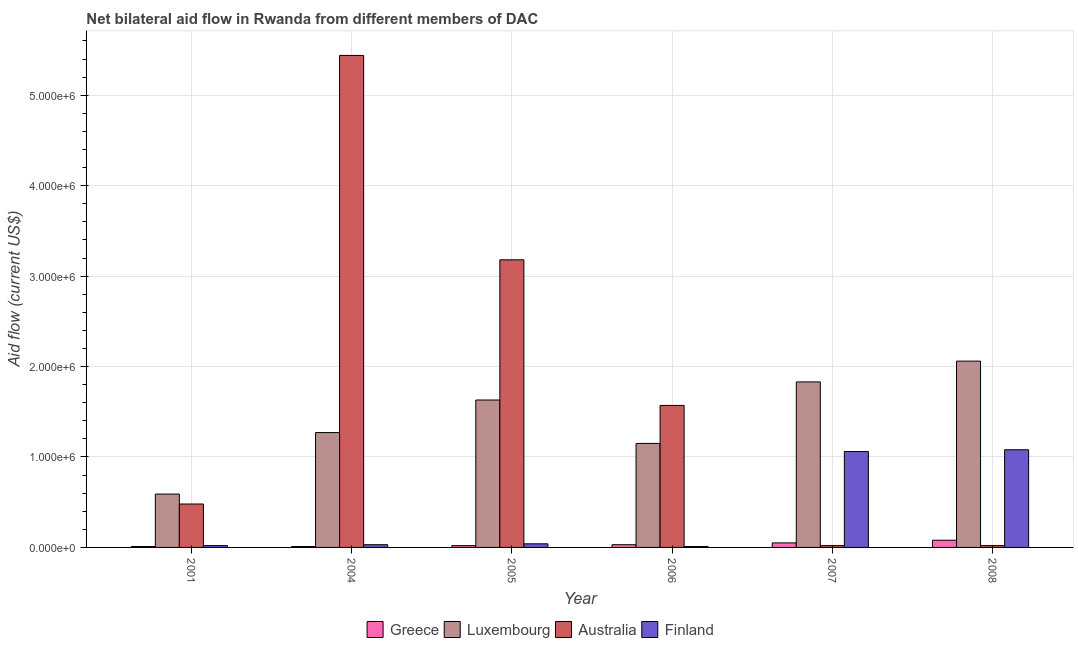How many groups of bars are there?
Offer a very short reply. 6. Are the number of bars per tick equal to the number of legend labels?
Give a very brief answer. Yes. How many bars are there on the 6th tick from the left?
Your response must be concise. 4. How many bars are there on the 1st tick from the right?
Your answer should be very brief. 4. What is the label of the 3rd group of bars from the left?
Give a very brief answer. 2005. What is the amount of aid given by greece in 2004?
Offer a very short reply. 10000. Across all years, what is the maximum amount of aid given by luxembourg?
Provide a short and direct response. 2.06e+06. Across all years, what is the minimum amount of aid given by finland?
Make the answer very short. 10000. In which year was the amount of aid given by luxembourg maximum?
Your response must be concise. 2008. What is the total amount of aid given by greece in the graph?
Make the answer very short. 2.00e+05. What is the difference between the amount of aid given by finland in 2001 and that in 2006?
Make the answer very short. 10000. What is the difference between the amount of aid given by finland in 2008 and the amount of aid given by luxembourg in 2004?
Provide a short and direct response. 1.05e+06. What is the average amount of aid given by greece per year?
Your response must be concise. 3.33e+04. In how many years, is the amount of aid given by australia greater than 3800000 US$?
Your answer should be very brief. 1. What is the ratio of the amount of aid given by finland in 2006 to that in 2008?
Offer a terse response. 0.01. Is the difference between the amount of aid given by finland in 2004 and 2007 greater than the difference between the amount of aid given by luxembourg in 2004 and 2007?
Offer a terse response. No. What is the difference between the highest and the second highest amount of aid given by luxembourg?
Ensure brevity in your answer.  2.30e+05. What is the difference between the highest and the lowest amount of aid given by greece?
Ensure brevity in your answer.  7.00e+04. In how many years, is the amount of aid given by australia greater than the average amount of aid given by australia taken over all years?
Offer a terse response. 2. Is it the case that in every year, the sum of the amount of aid given by luxembourg and amount of aid given by greece is greater than the sum of amount of aid given by australia and amount of aid given by finland?
Your answer should be very brief. Yes. What does the 2nd bar from the right in 2006 represents?
Give a very brief answer. Australia. Is it the case that in every year, the sum of the amount of aid given by greece and amount of aid given by luxembourg is greater than the amount of aid given by australia?
Make the answer very short. No. Are all the bars in the graph horizontal?
Provide a succinct answer. No. What is the difference between two consecutive major ticks on the Y-axis?
Your answer should be compact. 1.00e+06. Does the graph contain any zero values?
Make the answer very short. No. Does the graph contain grids?
Provide a succinct answer. Yes. What is the title of the graph?
Offer a terse response. Net bilateral aid flow in Rwanda from different members of DAC. Does "Interest Payments" appear as one of the legend labels in the graph?
Offer a very short reply. No. What is the Aid flow (current US$) of Greece in 2001?
Keep it short and to the point. 10000. What is the Aid flow (current US$) in Luxembourg in 2001?
Keep it short and to the point. 5.90e+05. What is the Aid flow (current US$) in Australia in 2001?
Keep it short and to the point. 4.80e+05. What is the Aid flow (current US$) in Finland in 2001?
Keep it short and to the point. 2.00e+04. What is the Aid flow (current US$) in Greece in 2004?
Provide a succinct answer. 10000. What is the Aid flow (current US$) of Luxembourg in 2004?
Offer a very short reply. 1.27e+06. What is the Aid flow (current US$) of Australia in 2004?
Offer a terse response. 5.44e+06. What is the Aid flow (current US$) of Finland in 2004?
Offer a very short reply. 3.00e+04. What is the Aid flow (current US$) in Luxembourg in 2005?
Ensure brevity in your answer.  1.63e+06. What is the Aid flow (current US$) in Australia in 2005?
Provide a short and direct response. 3.18e+06. What is the Aid flow (current US$) of Finland in 2005?
Provide a succinct answer. 4.00e+04. What is the Aid flow (current US$) of Luxembourg in 2006?
Keep it short and to the point. 1.15e+06. What is the Aid flow (current US$) in Australia in 2006?
Make the answer very short. 1.57e+06. What is the Aid flow (current US$) in Greece in 2007?
Offer a terse response. 5.00e+04. What is the Aid flow (current US$) of Luxembourg in 2007?
Offer a very short reply. 1.83e+06. What is the Aid flow (current US$) of Australia in 2007?
Give a very brief answer. 2.00e+04. What is the Aid flow (current US$) of Finland in 2007?
Ensure brevity in your answer.  1.06e+06. What is the Aid flow (current US$) in Greece in 2008?
Your answer should be very brief. 8.00e+04. What is the Aid flow (current US$) in Luxembourg in 2008?
Offer a very short reply. 2.06e+06. What is the Aid flow (current US$) in Finland in 2008?
Your answer should be compact. 1.08e+06. Across all years, what is the maximum Aid flow (current US$) of Greece?
Ensure brevity in your answer.  8.00e+04. Across all years, what is the maximum Aid flow (current US$) in Luxembourg?
Ensure brevity in your answer.  2.06e+06. Across all years, what is the maximum Aid flow (current US$) of Australia?
Make the answer very short. 5.44e+06. Across all years, what is the maximum Aid flow (current US$) in Finland?
Offer a terse response. 1.08e+06. Across all years, what is the minimum Aid flow (current US$) of Luxembourg?
Make the answer very short. 5.90e+05. Across all years, what is the minimum Aid flow (current US$) in Australia?
Ensure brevity in your answer.  2.00e+04. What is the total Aid flow (current US$) in Greece in the graph?
Offer a very short reply. 2.00e+05. What is the total Aid flow (current US$) in Luxembourg in the graph?
Keep it short and to the point. 8.53e+06. What is the total Aid flow (current US$) of Australia in the graph?
Provide a short and direct response. 1.07e+07. What is the total Aid flow (current US$) of Finland in the graph?
Offer a very short reply. 2.24e+06. What is the difference between the Aid flow (current US$) in Luxembourg in 2001 and that in 2004?
Your answer should be compact. -6.80e+05. What is the difference between the Aid flow (current US$) in Australia in 2001 and that in 2004?
Keep it short and to the point. -4.96e+06. What is the difference between the Aid flow (current US$) in Finland in 2001 and that in 2004?
Offer a terse response. -10000. What is the difference between the Aid flow (current US$) in Greece in 2001 and that in 2005?
Offer a terse response. -10000. What is the difference between the Aid flow (current US$) of Luxembourg in 2001 and that in 2005?
Keep it short and to the point. -1.04e+06. What is the difference between the Aid flow (current US$) of Australia in 2001 and that in 2005?
Offer a very short reply. -2.70e+06. What is the difference between the Aid flow (current US$) in Finland in 2001 and that in 2005?
Your answer should be compact. -2.00e+04. What is the difference between the Aid flow (current US$) in Luxembourg in 2001 and that in 2006?
Offer a very short reply. -5.60e+05. What is the difference between the Aid flow (current US$) of Australia in 2001 and that in 2006?
Offer a terse response. -1.09e+06. What is the difference between the Aid flow (current US$) in Finland in 2001 and that in 2006?
Keep it short and to the point. 10000. What is the difference between the Aid flow (current US$) of Luxembourg in 2001 and that in 2007?
Keep it short and to the point. -1.24e+06. What is the difference between the Aid flow (current US$) of Finland in 2001 and that in 2007?
Make the answer very short. -1.04e+06. What is the difference between the Aid flow (current US$) in Greece in 2001 and that in 2008?
Offer a very short reply. -7.00e+04. What is the difference between the Aid flow (current US$) in Luxembourg in 2001 and that in 2008?
Your answer should be compact. -1.47e+06. What is the difference between the Aid flow (current US$) of Australia in 2001 and that in 2008?
Offer a terse response. 4.60e+05. What is the difference between the Aid flow (current US$) in Finland in 2001 and that in 2008?
Your response must be concise. -1.06e+06. What is the difference between the Aid flow (current US$) of Luxembourg in 2004 and that in 2005?
Ensure brevity in your answer.  -3.60e+05. What is the difference between the Aid flow (current US$) of Australia in 2004 and that in 2005?
Keep it short and to the point. 2.26e+06. What is the difference between the Aid flow (current US$) of Luxembourg in 2004 and that in 2006?
Your answer should be compact. 1.20e+05. What is the difference between the Aid flow (current US$) in Australia in 2004 and that in 2006?
Offer a terse response. 3.87e+06. What is the difference between the Aid flow (current US$) in Greece in 2004 and that in 2007?
Your answer should be compact. -4.00e+04. What is the difference between the Aid flow (current US$) of Luxembourg in 2004 and that in 2007?
Your answer should be compact. -5.60e+05. What is the difference between the Aid flow (current US$) in Australia in 2004 and that in 2007?
Your response must be concise. 5.42e+06. What is the difference between the Aid flow (current US$) in Finland in 2004 and that in 2007?
Ensure brevity in your answer.  -1.03e+06. What is the difference between the Aid flow (current US$) in Luxembourg in 2004 and that in 2008?
Keep it short and to the point. -7.90e+05. What is the difference between the Aid flow (current US$) of Australia in 2004 and that in 2008?
Your response must be concise. 5.42e+06. What is the difference between the Aid flow (current US$) of Finland in 2004 and that in 2008?
Your answer should be compact. -1.05e+06. What is the difference between the Aid flow (current US$) in Greece in 2005 and that in 2006?
Ensure brevity in your answer.  -10000. What is the difference between the Aid flow (current US$) in Australia in 2005 and that in 2006?
Your response must be concise. 1.61e+06. What is the difference between the Aid flow (current US$) of Australia in 2005 and that in 2007?
Ensure brevity in your answer.  3.16e+06. What is the difference between the Aid flow (current US$) of Finland in 2005 and that in 2007?
Your answer should be compact. -1.02e+06. What is the difference between the Aid flow (current US$) in Greece in 2005 and that in 2008?
Keep it short and to the point. -6.00e+04. What is the difference between the Aid flow (current US$) in Luxembourg in 2005 and that in 2008?
Make the answer very short. -4.30e+05. What is the difference between the Aid flow (current US$) of Australia in 2005 and that in 2008?
Keep it short and to the point. 3.16e+06. What is the difference between the Aid flow (current US$) of Finland in 2005 and that in 2008?
Your answer should be very brief. -1.04e+06. What is the difference between the Aid flow (current US$) in Greece in 2006 and that in 2007?
Give a very brief answer. -2.00e+04. What is the difference between the Aid flow (current US$) in Luxembourg in 2006 and that in 2007?
Provide a succinct answer. -6.80e+05. What is the difference between the Aid flow (current US$) in Australia in 2006 and that in 2007?
Provide a succinct answer. 1.55e+06. What is the difference between the Aid flow (current US$) of Finland in 2006 and that in 2007?
Keep it short and to the point. -1.05e+06. What is the difference between the Aid flow (current US$) of Greece in 2006 and that in 2008?
Your response must be concise. -5.00e+04. What is the difference between the Aid flow (current US$) of Luxembourg in 2006 and that in 2008?
Provide a short and direct response. -9.10e+05. What is the difference between the Aid flow (current US$) in Australia in 2006 and that in 2008?
Keep it short and to the point. 1.55e+06. What is the difference between the Aid flow (current US$) of Finland in 2006 and that in 2008?
Offer a very short reply. -1.07e+06. What is the difference between the Aid flow (current US$) in Greece in 2007 and that in 2008?
Offer a terse response. -3.00e+04. What is the difference between the Aid flow (current US$) in Greece in 2001 and the Aid flow (current US$) in Luxembourg in 2004?
Give a very brief answer. -1.26e+06. What is the difference between the Aid flow (current US$) of Greece in 2001 and the Aid flow (current US$) of Australia in 2004?
Give a very brief answer. -5.43e+06. What is the difference between the Aid flow (current US$) of Luxembourg in 2001 and the Aid flow (current US$) of Australia in 2004?
Make the answer very short. -4.85e+06. What is the difference between the Aid flow (current US$) in Luxembourg in 2001 and the Aid flow (current US$) in Finland in 2004?
Your answer should be very brief. 5.60e+05. What is the difference between the Aid flow (current US$) in Australia in 2001 and the Aid flow (current US$) in Finland in 2004?
Provide a succinct answer. 4.50e+05. What is the difference between the Aid flow (current US$) in Greece in 2001 and the Aid flow (current US$) in Luxembourg in 2005?
Your response must be concise. -1.62e+06. What is the difference between the Aid flow (current US$) in Greece in 2001 and the Aid flow (current US$) in Australia in 2005?
Provide a succinct answer. -3.17e+06. What is the difference between the Aid flow (current US$) in Greece in 2001 and the Aid flow (current US$) in Finland in 2005?
Keep it short and to the point. -3.00e+04. What is the difference between the Aid flow (current US$) in Luxembourg in 2001 and the Aid flow (current US$) in Australia in 2005?
Ensure brevity in your answer.  -2.59e+06. What is the difference between the Aid flow (current US$) in Luxembourg in 2001 and the Aid flow (current US$) in Finland in 2005?
Provide a short and direct response. 5.50e+05. What is the difference between the Aid flow (current US$) in Australia in 2001 and the Aid flow (current US$) in Finland in 2005?
Your answer should be compact. 4.40e+05. What is the difference between the Aid flow (current US$) in Greece in 2001 and the Aid flow (current US$) in Luxembourg in 2006?
Provide a short and direct response. -1.14e+06. What is the difference between the Aid flow (current US$) of Greece in 2001 and the Aid flow (current US$) of Australia in 2006?
Keep it short and to the point. -1.56e+06. What is the difference between the Aid flow (current US$) of Greece in 2001 and the Aid flow (current US$) of Finland in 2006?
Your answer should be compact. 0. What is the difference between the Aid flow (current US$) in Luxembourg in 2001 and the Aid flow (current US$) in Australia in 2006?
Give a very brief answer. -9.80e+05. What is the difference between the Aid flow (current US$) of Luxembourg in 2001 and the Aid flow (current US$) of Finland in 2006?
Give a very brief answer. 5.80e+05. What is the difference between the Aid flow (current US$) in Greece in 2001 and the Aid flow (current US$) in Luxembourg in 2007?
Ensure brevity in your answer.  -1.82e+06. What is the difference between the Aid flow (current US$) of Greece in 2001 and the Aid flow (current US$) of Australia in 2007?
Give a very brief answer. -10000. What is the difference between the Aid flow (current US$) in Greece in 2001 and the Aid flow (current US$) in Finland in 2007?
Your response must be concise. -1.05e+06. What is the difference between the Aid flow (current US$) in Luxembourg in 2001 and the Aid flow (current US$) in Australia in 2007?
Provide a short and direct response. 5.70e+05. What is the difference between the Aid flow (current US$) in Luxembourg in 2001 and the Aid flow (current US$) in Finland in 2007?
Offer a very short reply. -4.70e+05. What is the difference between the Aid flow (current US$) in Australia in 2001 and the Aid flow (current US$) in Finland in 2007?
Offer a very short reply. -5.80e+05. What is the difference between the Aid flow (current US$) of Greece in 2001 and the Aid flow (current US$) of Luxembourg in 2008?
Offer a very short reply. -2.05e+06. What is the difference between the Aid flow (current US$) of Greece in 2001 and the Aid flow (current US$) of Australia in 2008?
Give a very brief answer. -10000. What is the difference between the Aid flow (current US$) of Greece in 2001 and the Aid flow (current US$) of Finland in 2008?
Make the answer very short. -1.07e+06. What is the difference between the Aid flow (current US$) in Luxembourg in 2001 and the Aid flow (current US$) in Australia in 2008?
Ensure brevity in your answer.  5.70e+05. What is the difference between the Aid flow (current US$) in Luxembourg in 2001 and the Aid flow (current US$) in Finland in 2008?
Offer a very short reply. -4.90e+05. What is the difference between the Aid flow (current US$) in Australia in 2001 and the Aid flow (current US$) in Finland in 2008?
Offer a very short reply. -6.00e+05. What is the difference between the Aid flow (current US$) of Greece in 2004 and the Aid flow (current US$) of Luxembourg in 2005?
Make the answer very short. -1.62e+06. What is the difference between the Aid flow (current US$) of Greece in 2004 and the Aid flow (current US$) of Australia in 2005?
Keep it short and to the point. -3.17e+06. What is the difference between the Aid flow (current US$) of Greece in 2004 and the Aid flow (current US$) of Finland in 2005?
Ensure brevity in your answer.  -3.00e+04. What is the difference between the Aid flow (current US$) in Luxembourg in 2004 and the Aid flow (current US$) in Australia in 2005?
Your answer should be compact. -1.91e+06. What is the difference between the Aid flow (current US$) of Luxembourg in 2004 and the Aid flow (current US$) of Finland in 2005?
Give a very brief answer. 1.23e+06. What is the difference between the Aid flow (current US$) in Australia in 2004 and the Aid flow (current US$) in Finland in 2005?
Make the answer very short. 5.40e+06. What is the difference between the Aid flow (current US$) in Greece in 2004 and the Aid flow (current US$) in Luxembourg in 2006?
Provide a succinct answer. -1.14e+06. What is the difference between the Aid flow (current US$) of Greece in 2004 and the Aid flow (current US$) of Australia in 2006?
Offer a very short reply. -1.56e+06. What is the difference between the Aid flow (current US$) in Luxembourg in 2004 and the Aid flow (current US$) in Finland in 2006?
Your answer should be compact. 1.26e+06. What is the difference between the Aid flow (current US$) in Australia in 2004 and the Aid flow (current US$) in Finland in 2006?
Keep it short and to the point. 5.43e+06. What is the difference between the Aid flow (current US$) of Greece in 2004 and the Aid flow (current US$) of Luxembourg in 2007?
Your answer should be very brief. -1.82e+06. What is the difference between the Aid flow (current US$) of Greece in 2004 and the Aid flow (current US$) of Australia in 2007?
Provide a short and direct response. -10000. What is the difference between the Aid flow (current US$) of Greece in 2004 and the Aid flow (current US$) of Finland in 2007?
Your answer should be compact. -1.05e+06. What is the difference between the Aid flow (current US$) of Luxembourg in 2004 and the Aid flow (current US$) of Australia in 2007?
Offer a very short reply. 1.25e+06. What is the difference between the Aid flow (current US$) in Luxembourg in 2004 and the Aid flow (current US$) in Finland in 2007?
Your answer should be compact. 2.10e+05. What is the difference between the Aid flow (current US$) in Australia in 2004 and the Aid flow (current US$) in Finland in 2007?
Make the answer very short. 4.38e+06. What is the difference between the Aid flow (current US$) in Greece in 2004 and the Aid flow (current US$) in Luxembourg in 2008?
Provide a succinct answer. -2.05e+06. What is the difference between the Aid flow (current US$) in Greece in 2004 and the Aid flow (current US$) in Finland in 2008?
Offer a very short reply. -1.07e+06. What is the difference between the Aid flow (current US$) of Luxembourg in 2004 and the Aid flow (current US$) of Australia in 2008?
Make the answer very short. 1.25e+06. What is the difference between the Aid flow (current US$) of Luxembourg in 2004 and the Aid flow (current US$) of Finland in 2008?
Keep it short and to the point. 1.90e+05. What is the difference between the Aid flow (current US$) of Australia in 2004 and the Aid flow (current US$) of Finland in 2008?
Your answer should be compact. 4.36e+06. What is the difference between the Aid flow (current US$) in Greece in 2005 and the Aid flow (current US$) in Luxembourg in 2006?
Provide a succinct answer. -1.13e+06. What is the difference between the Aid flow (current US$) in Greece in 2005 and the Aid flow (current US$) in Australia in 2006?
Offer a terse response. -1.55e+06. What is the difference between the Aid flow (current US$) in Greece in 2005 and the Aid flow (current US$) in Finland in 2006?
Make the answer very short. 10000. What is the difference between the Aid flow (current US$) in Luxembourg in 2005 and the Aid flow (current US$) in Australia in 2006?
Ensure brevity in your answer.  6.00e+04. What is the difference between the Aid flow (current US$) of Luxembourg in 2005 and the Aid flow (current US$) of Finland in 2006?
Your answer should be very brief. 1.62e+06. What is the difference between the Aid flow (current US$) of Australia in 2005 and the Aid flow (current US$) of Finland in 2006?
Your answer should be compact. 3.17e+06. What is the difference between the Aid flow (current US$) in Greece in 2005 and the Aid flow (current US$) in Luxembourg in 2007?
Make the answer very short. -1.81e+06. What is the difference between the Aid flow (current US$) of Greece in 2005 and the Aid flow (current US$) of Finland in 2007?
Give a very brief answer. -1.04e+06. What is the difference between the Aid flow (current US$) in Luxembourg in 2005 and the Aid flow (current US$) in Australia in 2007?
Give a very brief answer. 1.61e+06. What is the difference between the Aid flow (current US$) of Luxembourg in 2005 and the Aid flow (current US$) of Finland in 2007?
Provide a succinct answer. 5.70e+05. What is the difference between the Aid flow (current US$) in Australia in 2005 and the Aid flow (current US$) in Finland in 2007?
Provide a short and direct response. 2.12e+06. What is the difference between the Aid flow (current US$) in Greece in 2005 and the Aid flow (current US$) in Luxembourg in 2008?
Your answer should be very brief. -2.04e+06. What is the difference between the Aid flow (current US$) in Greece in 2005 and the Aid flow (current US$) in Australia in 2008?
Give a very brief answer. 0. What is the difference between the Aid flow (current US$) in Greece in 2005 and the Aid flow (current US$) in Finland in 2008?
Offer a very short reply. -1.06e+06. What is the difference between the Aid flow (current US$) in Luxembourg in 2005 and the Aid flow (current US$) in Australia in 2008?
Offer a terse response. 1.61e+06. What is the difference between the Aid flow (current US$) in Luxembourg in 2005 and the Aid flow (current US$) in Finland in 2008?
Your answer should be very brief. 5.50e+05. What is the difference between the Aid flow (current US$) in Australia in 2005 and the Aid flow (current US$) in Finland in 2008?
Provide a succinct answer. 2.10e+06. What is the difference between the Aid flow (current US$) of Greece in 2006 and the Aid flow (current US$) of Luxembourg in 2007?
Make the answer very short. -1.80e+06. What is the difference between the Aid flow (current US$) in Greece in 2006 and the Aid flow (current US$) in Finland in 2007?
Give a very brief answer. -1.03e+06. What is the difference between the Aid flow (current US$) in Luxembourg in 2006 and the Aid flow (current US$) in Australia in 2007?
Your response must be concise. 1.13e+06. What is the difference between the Aid flow (current US$) in Luxembourg in 2006 and the Aid flow (current US$) in Finland in 2007?
Your answer should be very brief. 9.00e+04. What is the difference between the Aid flow (current US$) of Australia in 2006 and the Aid flow (current US$) of Finland in 2007?
Offer a terse response. 5.10e+05. What is the difference between the Aid flow (current US$) in Greece in 2006 and the Aid flow (current US$) in Luxembourg in 2008?
Your answer should be very brief. -2.03e+06. What is the difference between the Aid flow (current US$) of Greece in 2006 and the Aid flow (current US$) of Finland in 2008?
Your answer should be very brief. -1.05e+06. What is the difference between the Aid flow (current US$) of Luxembourg in 2006 and the Aid flow (current US$) of Australia in 2008?
Keep it short and to the point. 1.13e+06. What is the difference between the Aid flow (current US$) in Greece in 2007 and the Aid flow (current US$) in Luxembourg in 2008?
Give a very brief answer. -2.01e+06. What is the difference between the Aid flow (current US$) of Greece in 2007 and the Aid flow (current US$) of Australia in 2008?
Keep it short and to the point. 3.00e+04. What is the difference between the Aid flow (current US$) in Greece in 2007 and the Aid flow (current US$) in Finland in 2008?
Provide a short and direct response. -1.03e+06. What is the difference between the Aid flow (current US$) in Luxembourg in 2007 and the Aid flow (current US$) in Australia in 2008?
Provide a succinct answer. 1.81e+06. What is the difference between the Aid flow (current US$) in Luxembourg in 2007 and the Aid flow (current US$) in Finland in 2008?
Provide a short and direct response. 7.50e+05. What is the difference between the Aid flow (current US$) in Australia in 2007 and the Aid flow (current US$) in Finland in 2008?
Provide a short and direct response. -1.06e+06. What is the average Aid flow (current US$) of Greece per year?
Your answer should be compact. 3.33e+04. What is the average Aid flow (current US$) in Luxembourg per year?
Give a very brief answer. 1.42e+06. What is the average Aid flow (current US$) of Australia per year?
Ensure brevity in your answer.  1.78e+06. What is the average Aid flow (current US$) in Finland per year?
Your response must be concise. 3.73e+05. In the year 2001, what is the difference between the Aid flow (current US$) in Greece and Aid flow (current US$) in Luxembourg?
Make the answer very short. -5.80e+05. In the year 2001, what is the difference between the Aid flow (current US$) of Greece and Aid flow (current US$) of Australia?
Offer a very short reply. -4.70e+05. In the year 2001, what is the difference between the Aid flow (current US$) of Luxembourg and Aid flow (current US$) of Australia?
Ensure brevity in your answer.  1.10e+05. In the year 2001, what is the difference between the Aid flow (current US$) of Luxembourg and Aid flow (current US$) of Finland?
Make the answer very short. 5.70e+05. In the year 2001, what is the difference between the Aid flow (current US$) of Australia and Aid flow (current US$) of Finland?
Offer a very short reply. 4.60e+05. In the year 2004, what is the difference between the Aid flow (current US$) of Greece and Aid flow (current US$) of Luxembourg?
Keep it short and to the point. -1.26e+06. In the year 2004, what is the difference between the Aid flow (current US$) of Greece and Aid flow (current US$) of Australia?
Your answer should be very brief. -5.43e+06. In the year 2004, what is the difference between the Aid flow (current US$) of Luxembourg and Aid flow (current US$) of Australia?
Your answer should be compact. -4.17e+06. In the year 2004, what is the difference between the Aid flow (current US$) of Luxembourg and Aid flow (current US$) of Finland?
Your answer should be very brief. 1.24e+06. In the year 2004, what is the difference between the Aid flow (current US$) of Australia and Aid flow (current US$) of Finland?
Ensure brevity in your answer.  5.41e+06. In the year 2005, what is the difference between the Aid flow (current US$) in Greece and Aid flow (current US$) in Luxembourg?
Your answer should be very brief. -1.61e+06. In the year 2005, what is the difference between the Aid flow (current US$) in Greece and Aid flow (current US$) in Australia?
Make the answer very short. -3.16e+06. In the year 2005, what is the difference between the Aid flow (current US$) of Luxembourg and Aid flow (current US$) of Australia?
Keep it short and to the point. -1.55e+06. In the year 2005, what is the difference between the Aid flow (current US$) in Luxembourg and Aid flow (current US$) in Finland?
Ensure brevity in your answer.  1.59e+06. In the year 2005, what is the difference between the Aid flow (current US$) of Australia and Aid flow (current US$) of Finland?
Your response must be concise. 3.14e+06. In the year 2006, what is the difference between the Aid flow (current US$) in Greece and Aid flow (current US$) in Luxembourg?
Your response must be concise. -1.12e+06. In the year 2006, what is the difference between the Aid flow (current US$) of Greece and Aid flow (current US$) of Australia?
Provide a succinct answer. -1.54e+06. In the year 2006, what is the difference between the Aid flow (current US$) of Luxembourg and Aid flow (current US$) of Australia?
Offer a terse response. -4.20e+05. In the year 2006, what is the difference between the Aid flow (current US$) of Luxembourg and Aid flow (current US$) of Finland?
Keep it short and to the point. 1.14e+06. In the year 2006, what is the difference between the Aid flow (current US$) of Australia and Aid flow (current US$) of Finland?
Offer a terse response. 1.56e+06. In the year 2007, what is the difference between the Aid flow (current US$) in Greece and Aid flow (current US$) in Luxembourg?
Provide a succinct answer. -1.78e+06. In the year 2007, what is the difference between the Aid flow (current US$) in Greece and Aid flow (current US$) in Australia?
Provide a succinct answer. 3.00e+04. In the year 2007, what is the difference between the Aid flow (current US$) of Greece and Aid flow (current US$) of Finland?
Offer a very short reply. -1.01e+06. In the year 2007, what is the difference between the Aid flow (current US$) in Luxembourg and Aid flow (current US$) in Australia?
Your response must be concise. 1.81e+06. In the year 2007, what is the difference between the Aid flow (current US$) in Luxembourg and Aid flow (current US$) in Finland?
Keep it short and to the point. 7.70e+05. In the year 2007, what is the difference between the Aid flow (current US$) in Australia and Aid flow (current US$) in Finland?
Your answer should be very brief. -1.04e+06. In the year 2008, what is the difference between the Aid flow (current US$) of Greece and Aid flow (current US$) of Luxembourg?
Provide a short and direct response. -1.98e+06. In the year 2008, what is the difference between the Aid flow (current US$) of Greece and Aid flow (current US$) of Australia?
Offer a very short reply. 6.00e+04. In the year 2008, what is the difference between the Aid flow (current US$) of Greece and Aid flow (current US$) of Finland?
Give a very brief answer. -1.00e+06. In the year 2008, what is the difference between the Aid flow (current US$) in Luxembourg and Aid flow (current US$) in Australia?
Give a very brief answer. 2.04e+06. In the year 2008, what is the difference between the Aid flow (current US$) in Luxembourg and Aid flow (current US$) in Finland?
Offer a terse response. 9.80e+05. In the year 2008, what is the difference between the Aid flow (current US$) of Australia and Aid flow (current US$) of Finland?
Your answer should be very brief. -1.06e+06. What is the ratio of the Aid flow (current US$) of Greece in 2001 to that in 2004?
Offer a terse response. 1. What is the ratio of the Aid flow (current US$) of Luxembourg in 2001 to that in 2004?
Make the answer very short. 0.46. What is the ratio of the Aid flow (current US$) of Australia in 2001 to that in 2004?
Provide a short and direct response. 0.09. What is the ratio of the Aid flow (current US$) of Greece in 2001 to that in 2005?
Keep it short and to the point. 0.5. What is the ratio of the Aid flow (current US$) of Luxembourg in 2001 to that in 2005?
Your response must be concise. 0.36. What is the ratio of the Aid flow (current US$) in Australia in 2001 to that in 2005?
Your answer should be compact. 0.15. What is the ratio of the Aid flow (current US$) of Greece in 2001 to that in 2006?
Ensure brevity in your answer.  0.33. What is the ratio of the Aid flow (current US$) in Luxembourg in 2001 to that in 2006?
Make the answer very short. 0.51. What is the ratio of the Aid flow (current US$) of Australia in 2001 to that in 2006?
Offer a very short reply. 0.31. What is the ratio of the Aid flow (current US$) in Finland in 2001 to that in 2006?
Provide a short and direct response. 2. What is the ratio of the Aid flow (current US$) in Luxembourg in 2001 to that in 2007?
Offer a very short reply. 0.32. What is the ratio of the Aid flow (current US$) in Australia in 2001 to that in 2007?
Your answer should be compact. 24. What is the ratio of the Aid flow (current US$) in Finland in 2001 to that in 2007?
Make the answer very short. 0.02. What is the ratio of the Aid flow (current US$) of Greece in 2001 to that in 2008?
Give a very brief answer. 0.12. What is the ratio of the Aid flow (current US$) of Luxembourg in 2001 to that in 2008?
Give a very brief answer. 0.29. What is the ratio of the Aid flow (current US$) in Finland in 2001 to that in 2008?
Provide a short and direct response. 0.02. What is the ratio of the Aid flow (current US$) of Luxembourg in 2004 to that in 2005?
Provide a short and direct response. 0.78. What is the ratio of the Aid flow (current US$) of Australia in 2004 to that in 2005?
Offer a very short reply. 1.71. What is the ratio of the Aid flow (current US$) in Finland in 2004 to that in 2005?
Your response must be concise. 0.75. What is the ratio of the Aid flow (current US$) of Luxembourg in 2004 to that in 2006?
Offer a very short reply. 1.1. What is the ratio of the Aid flow (current US$) of Australia in 2004 to that in 2006?
Ensure brevity in your answer.  3.46. What is the ratio of the Aid flow (current US$) in Finland in 2004 to that in 2006?
Offer a terse response. 3. What is the ratio of the Aid flow (current US$) of Luxembourg in 2004 to that in 2007?
Provide a succinct answer. 0.69. What is the ratio of the Aid flow (current US$) in Australia in 2004 to that in 2007?
Your answer should be very brief. 272. What is the ratio of the Aid flow (current US$) of Finland in 2004 to that in 2007?
Provide a succinct answer. 0.03. What is the ratio of the Aid flow (current US$) of Greece in 2004 to that in 2008?
Your answer should be very brief. 0.12. What is the ratio of the Aid flow (current US$) in Luxembourg in 2004 to that in 2008?
Provide a succinct answer. 0.62. What is the ratio of the Aid flow (current US$) in Australia in 2004 to that in 2008?
Offer a very short reply. 272. What is the ratio of the Aid flow (current US$) in Finland in 2004 to that in 2008?
Provide a succinct answer. 0.03. What is the ratio of the Aid flow (current US$) in Greece in 2005 to that in 2006?
Ensure brevity in your answer.  0.67. What is the ratio of the Aid flow (current US$) in Luxembourg in 2005 to that in 2006?
Ensure brevity in your answer.  1.42. What is the ratio of the Aid flow (current US$) in Australia in 2005 to that in 2006?
Provide a succinct answer. 2.03. What is the ratio of the Aid flow (current US$) in Finland in 2005 to that in 2006?
Make the answer very short. 4. What is the ratio of the Aid flow (current US$) in Luxembourg in 2005 to that in 2007?
Give a very brief answer. 0.89. What is the ratio of the Aid flow (current US$) of Australia in 2005 to that in 2007?
Keep it short and to the point. 159. What is the ratio of the Aid flow (current US$) in Finland in 2005 to that in 2007?
Your answer should be very brief. 0.04. What is the ratio of the Aid flow (current US$) of Luxembourg in 2005 to that in 2008?
Provide a succinct answer. 0.79. What is the ratio of the Aid flow (current US$) of Australia in 2005 to that in 2008?
Your answer should be very brief. 159. What is the ratio of the Aid flow (current US$) of Finland in 2005 to that in 2008?
Give a very brief answer. 0.04. What is the ratio of the Aid flow (current US$) in Greece in 2006 to that in 2007?
Keep it short and to the point. 0.6. What is the ratio of the Aid flow (current US$) in Luxembourg in 2006 to that in 2007?
Offer a terse response. 0.63. What is the ratio of the Aid flow (current US$) in Australia in 2006 to that in 2007?
Your answer should be compact. 78.5. What is the ratio of the Aid flow (current US$) of Finland in 2006 to that in 2007?
Your answer should be compact. 0.01. What is the ratio of the Aid flow (current US$) in Greece in 2006 to that in 2008?
Ensure brevity in your answer.  0.38. What is the ratio of the Aid flow (current US$) in Luxembourg in 2006 to that in 2008?
Provide a succinct answer. 0.56. What is the ratio of the Aid flow (current US$) in Australia in 2006 to that in 2008?
Keep it short and to the point. 78.5. What is the ratio of the Aid flow (current US$) of Finland in 2006 to that in 2008?
Your answer should be very brief. 0.01. What is the ratio of the Aid flow (current US$) of Luxembourg in 2007 to that in 2008?
Your answer should be compact. 0.89. What is the ratio of the Aid flow (current US$) of Australia in 2007 to that in 2008?
Give a very brief answer. 1. What is the ratio of the Aid flow (current US$) in Finland in 2007 to that in 2008?
Your answer should be compact. 0.98. What is the difference between the highest and the second highest Aid flow (current US$) in Australia?
Keep it short and to the point. 2.26e+06. What is the difference between the highest and the lowest Aid flow (current US$) in Luxembourg?
Offer a terse response. 1.47e+06. What is the difference between the highest and the lowest Aid flow (current US$) in Australia?
Ensure brevity in your answer.  5.42e+06. What is the difference between the highest and the lowest Aid flow (current US$) of Finland?
Keep it short and to the point. 1.07e+06. 